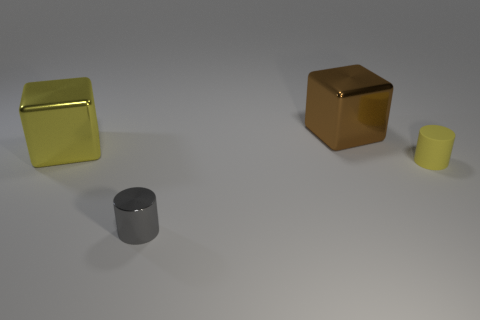Is there a brown metal thing of the same shape as the tiny gray metal thing?
Your response must be concise. No. Is the tiny gray shiny object the same shape as the large brown shiny object?
Offer a terse response. No. What color is the large object right of the small gray metallic object on the left side of the tiny rubber object?
Your answer should be very brief. Brown. The other metallic cube that is the same size as the yellow metal block is what color?
Keep it short and to the point. Brown. How many matte things are either cyan things or small gray objects?
Give a very brief answer. 0. How many big shiny things are right of the small yellow matte cylinder that is to the right of the tiny metallic thing?
Your answer should be very brief. 0. There is a metal thing that is the same color as the small rubber cylinder; what is its size?
Your answer should be very brief. Large. How many things are tiny yellow objects or things that are behind the small gray cylinder?
Offer a terse response. 3. Is there a small brown thing that has the same material as the small yellow object?
Give a very brief answer. No. What number of objects are both in front of the large yellow cube and behind the small gray metallic thing?
Make the answer very short. 1. 